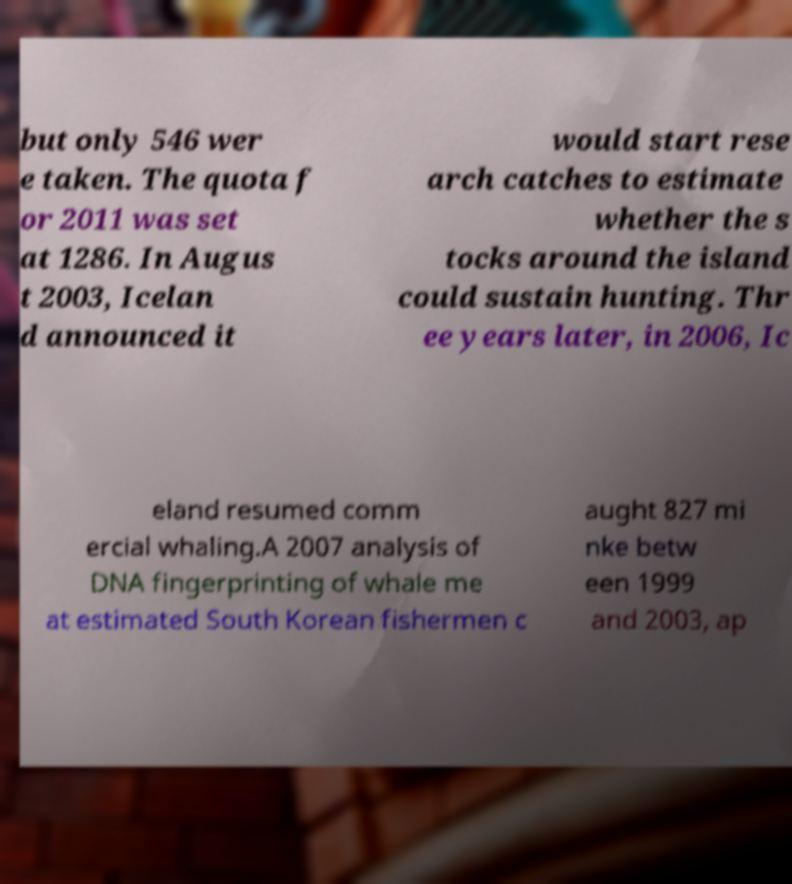For documentation purposes, I need the text within this image transcribed. Could you provide that? but only 546 wer e taken. The quota f or 2011 was set at 1286. In Augus t 2003, Icelan d announced it would start rese arch catches to estimate whether the s tocks around the island could sustain hunting. Thr ee years later, in 2006, Ic eland resumed comm ercial whaling.A 2007 analysis of DNA fingerprinting of whale me at estimated South Korean fishermen c aught 827 mi nke betw een 1999 and 2003, ap 